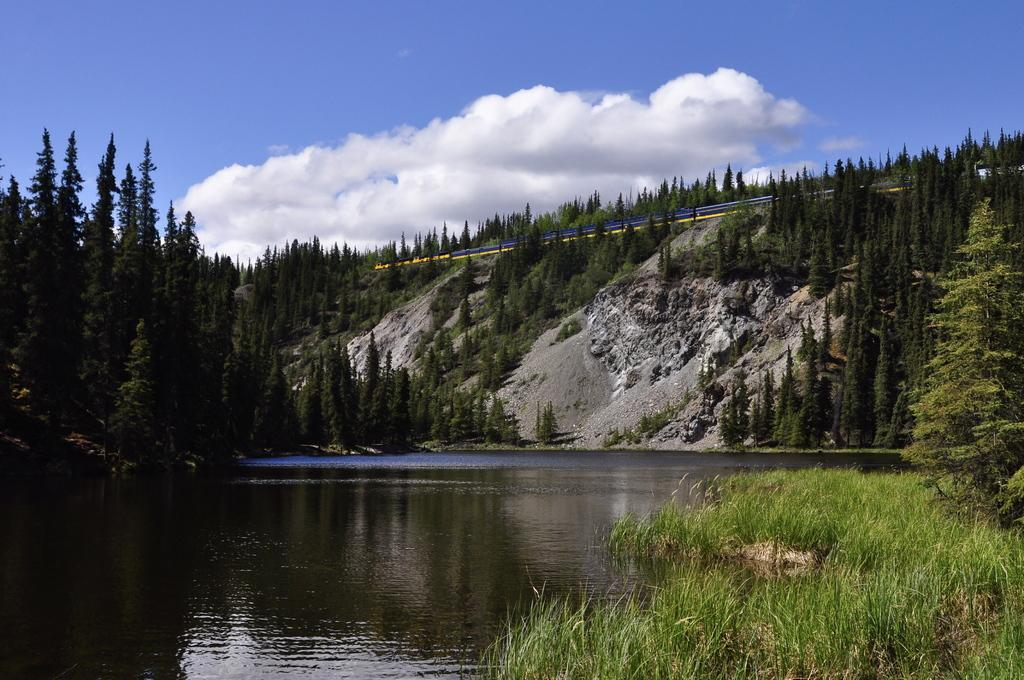What is the main feature in the center of the image? There is water in the center of the image. What type of vegetation can be seen on the right side of the image? There is grass on the right side of the image. What other natural elements are visible in the image? There are trees visible in the image. What can be seen in the background of the image? Clouds and the sky are present in the background of the image. How many steps does the son take in the image? There is no son present in the image, and therefore no steps can be counted. What type of patch can be seen on the trees in the image? There are no patches visible on the trees in the image. 